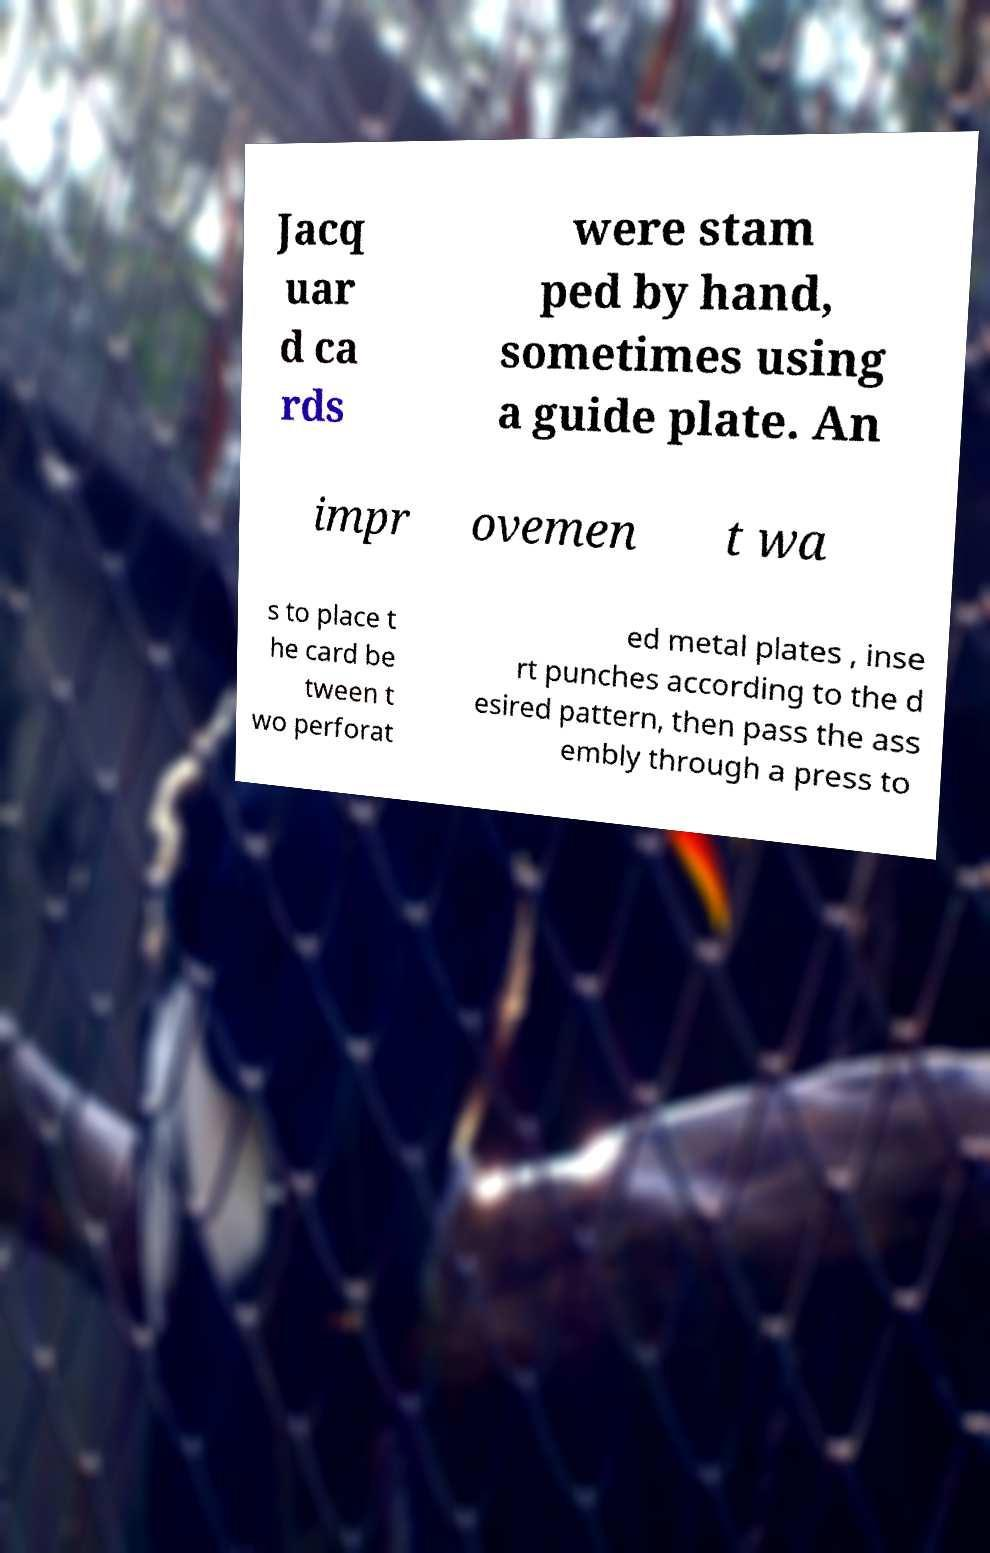Could you assist in decoding the text presented in this image and type it out clearly? Jacq uar d ca rds were stam ped by hand, sometimes using a guide plate. An impr ovemen t wa s to place t he card be tween t wo perforat ed metal plates , inse rt punches according to the d esired pattern, then pass the ass embly through a press to 